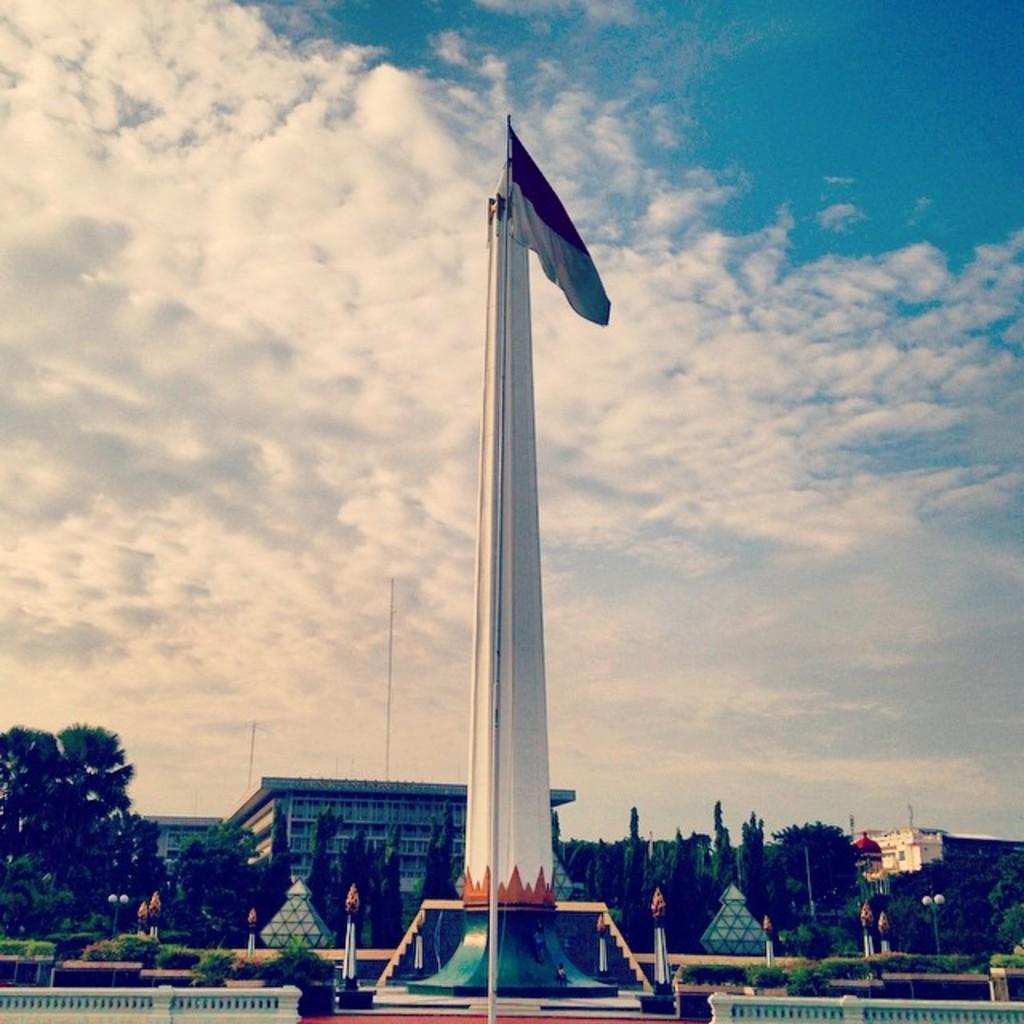Describe this image in one or two sentences. In this image, in the middle we can see a pillar and a flag, there are some trees, we can see a building, at the top we can see the sky. 